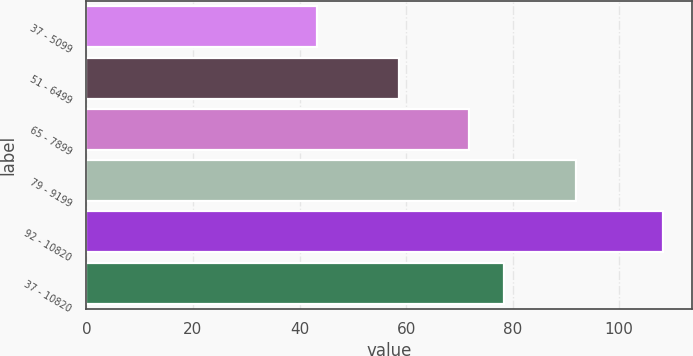Convert chart. <chart><loc_0><loc_0><loc_500><loc_500><bar_chart><fcel>37 - 5099<fcel>51 - 6499<fcel>65 - 7899<fcel>79 - 9199<fcel>92 - 10820<fcel>37 - 10820<nl><fcel>43.22<fcel>58.58<fcel>71.86<fcel>91.82<fcel>108.2<fcel>78.36<nl></chart> 